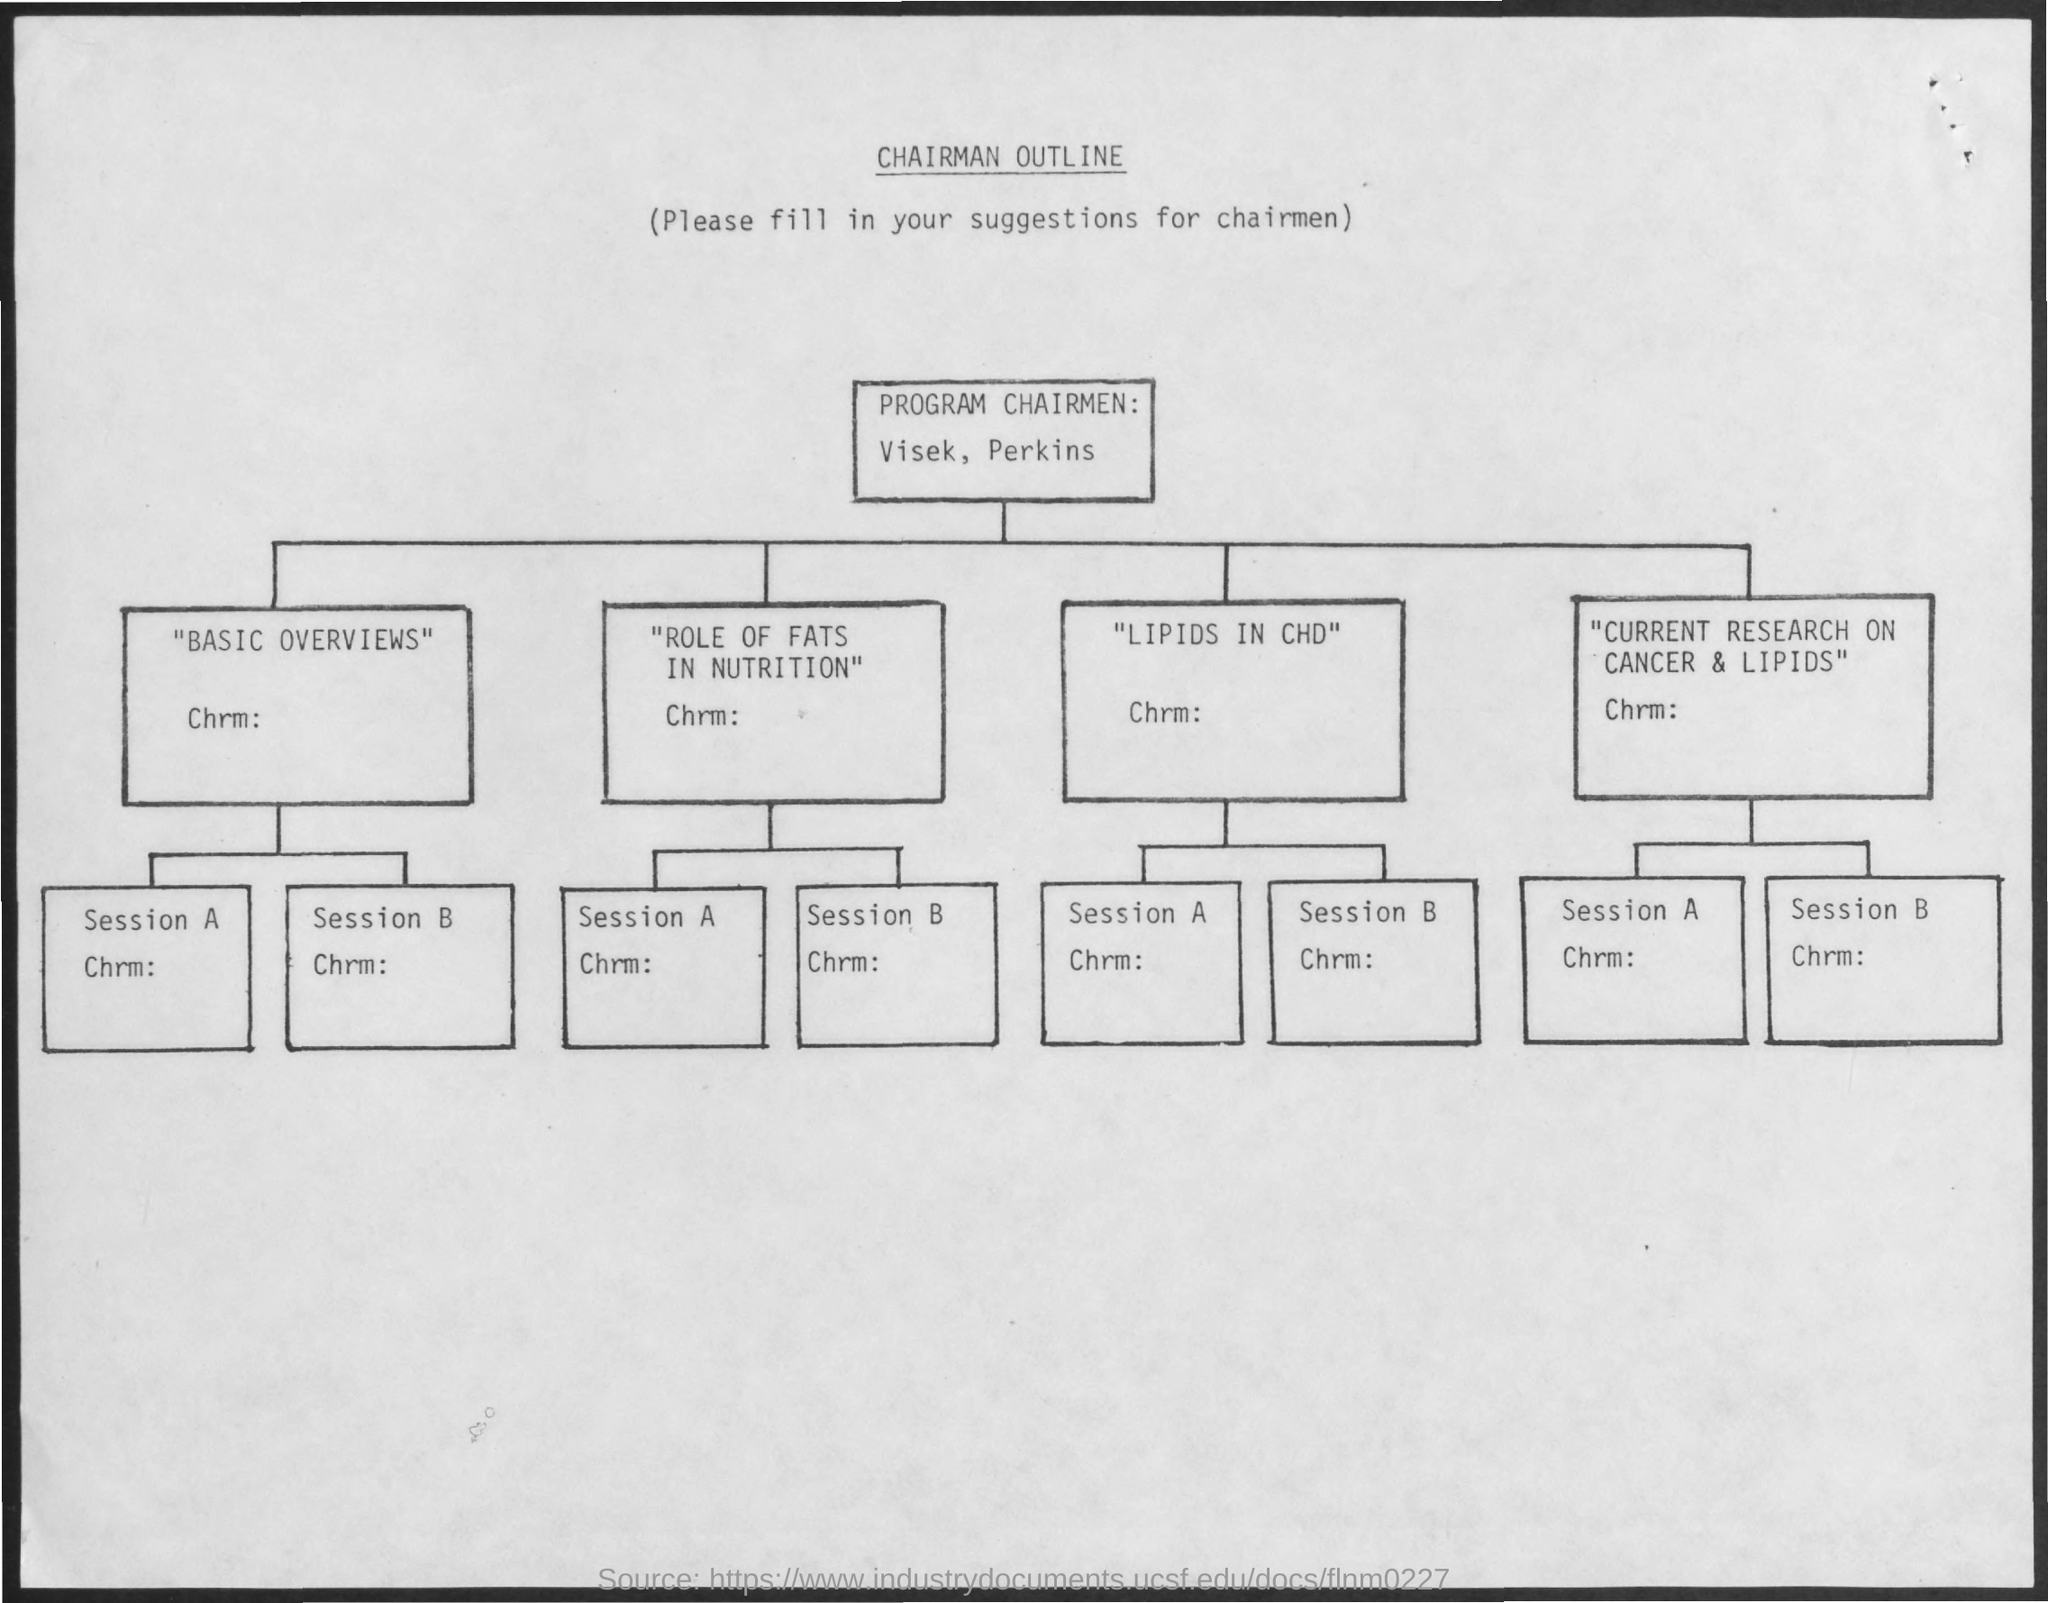What is the Title of the document?
Ensure brevity in your answer.  Chairman outline. 